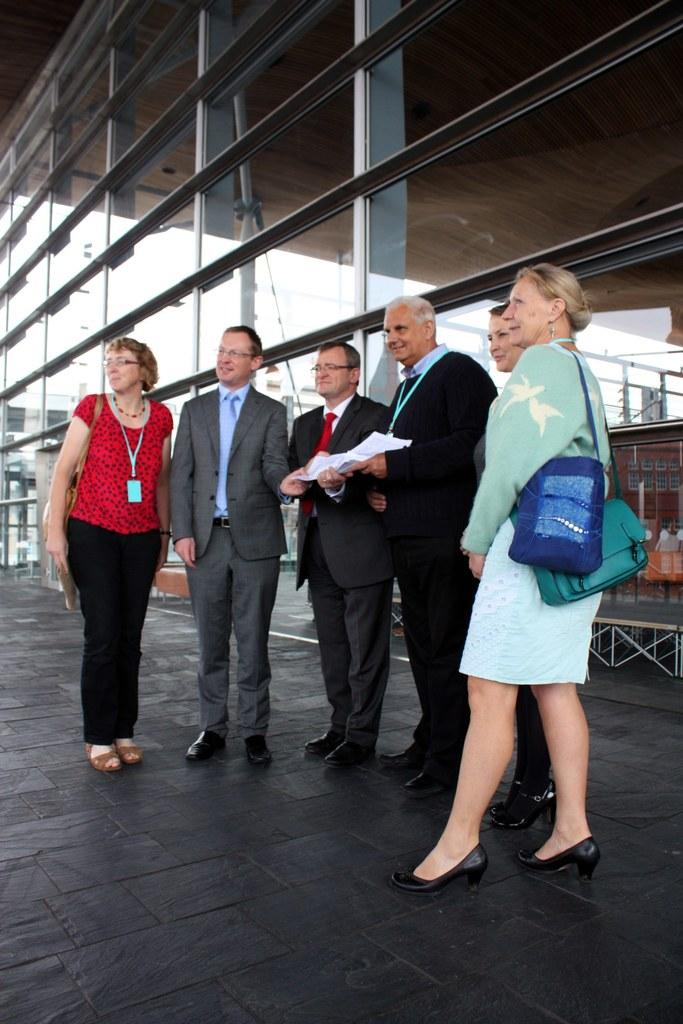What can be observed about the people in the image? There are people standing in the image, including some guys and three ladies. What are the ladies wearing in the image? The ladies are wearing bags in the image. What is present in the background of the image? There is a glass wall in the background of the image. What other objects can be seen in the image? There are poles visible in the image. What is the aftermath of the ice in the image? There is no ice present in the image, so there is no aftermath to discuss. What type of game is being played in the image? There is no game being played in the image; it features people standing and wearing bags. 